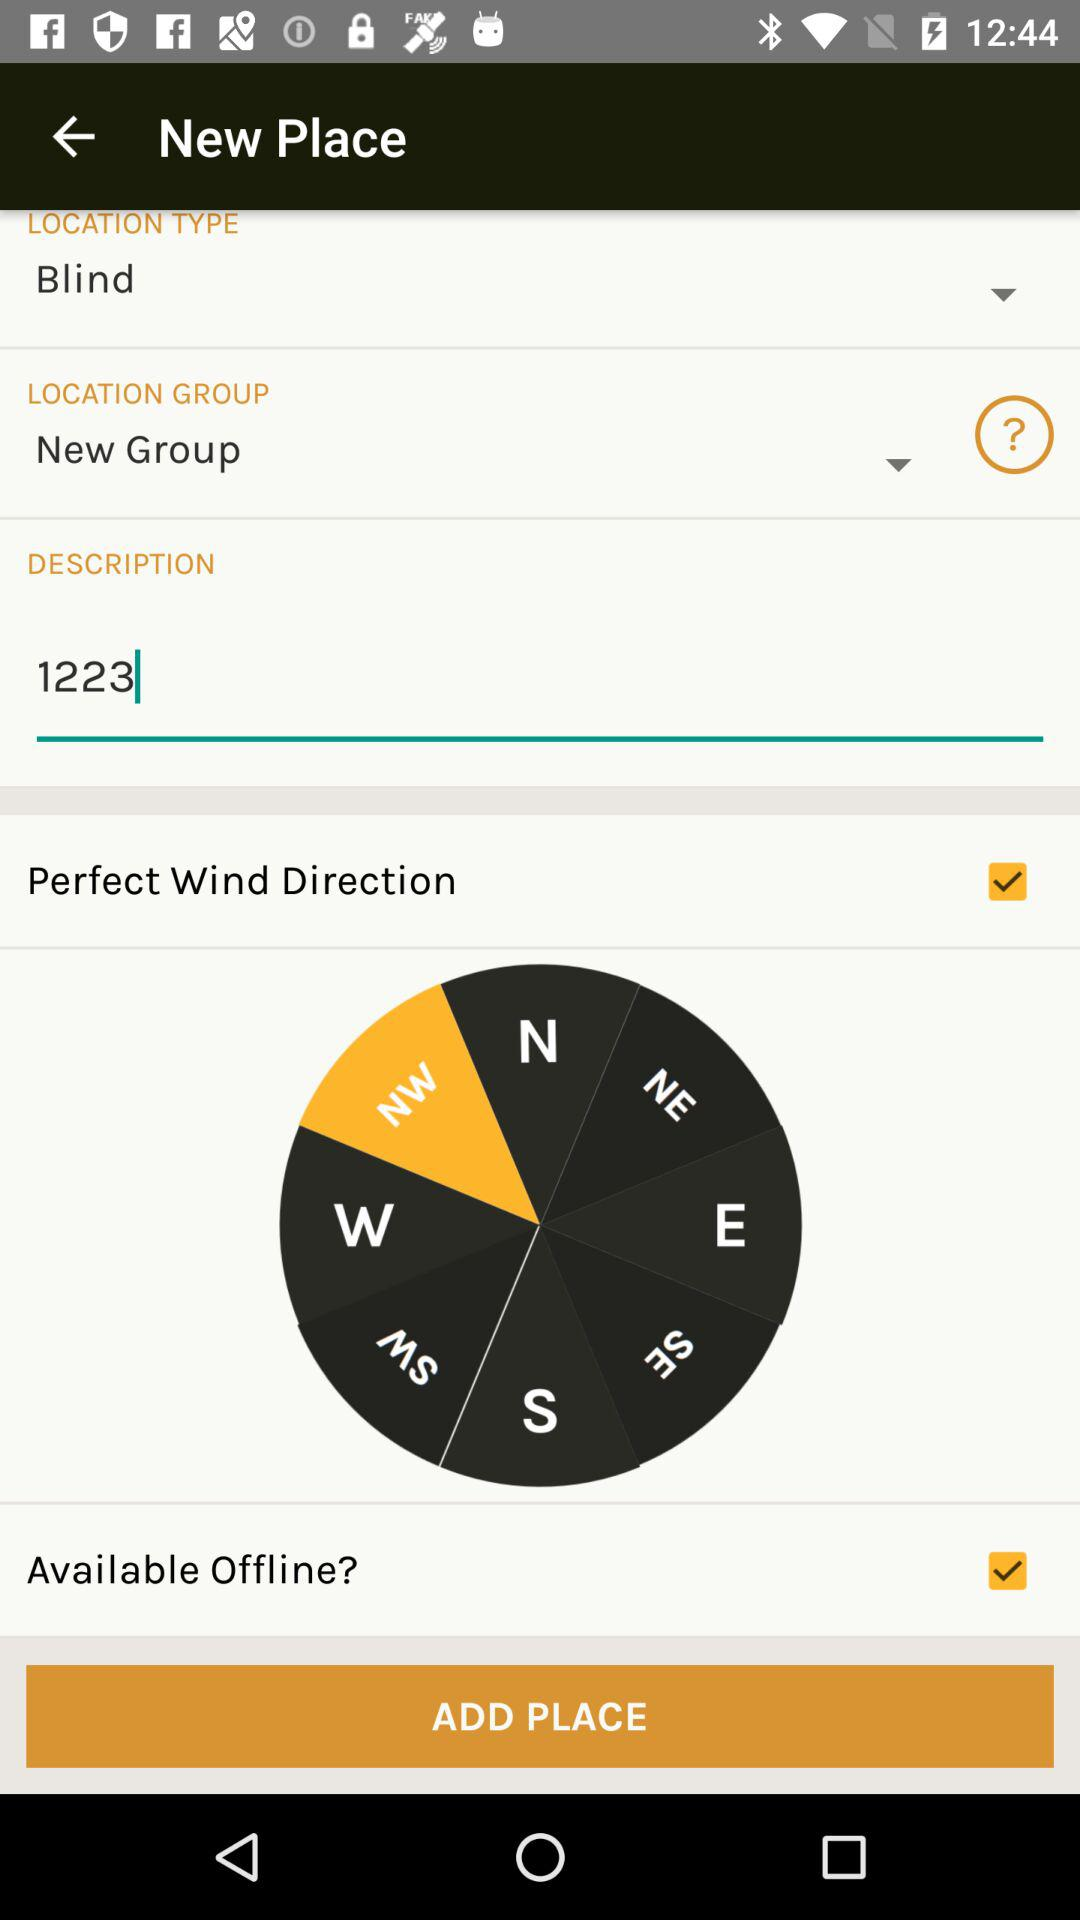What is the number entered in the description? The number entered in the description is 1223. 